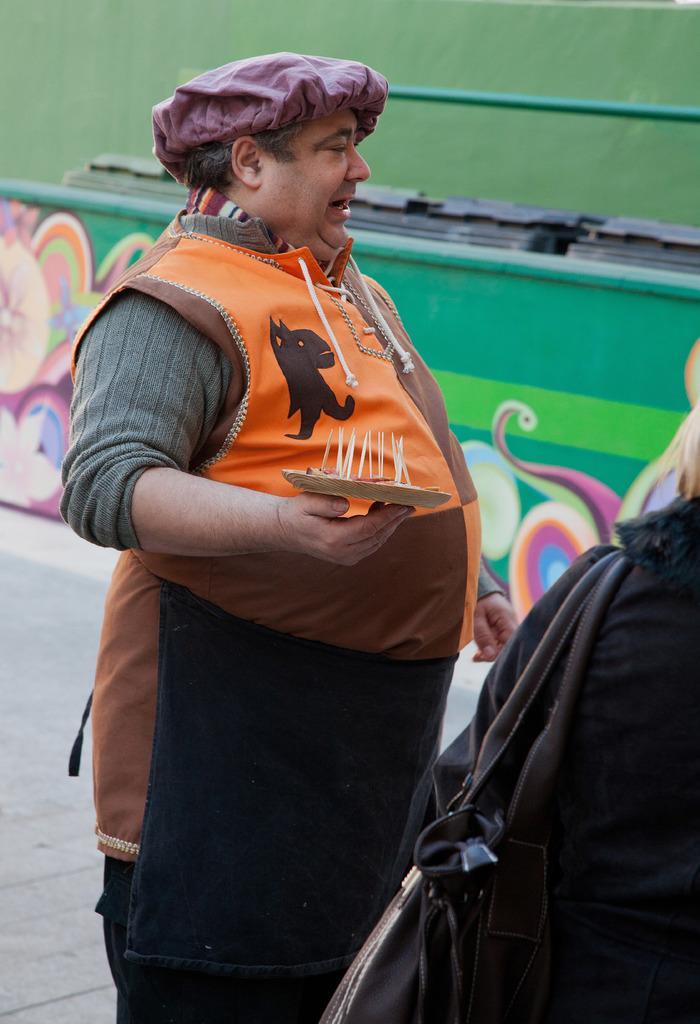Describe this image in one or two sentences. This image consists of two persons. In the front, there is a man holding a plate. He is wearing an apron. At the bottom, there is a road. In the background, there is a wall and a green color board. 